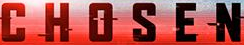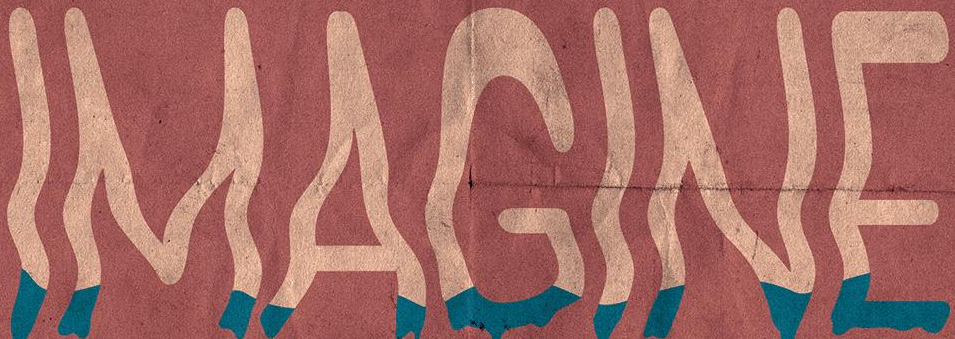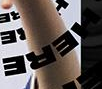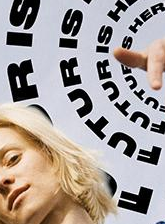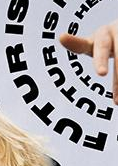What text appears in these images from left to right, separated by a semicolon? CHOSEN; IMAGINE; HERE; FUTURIS; FUTURIS 